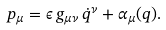Convert formula to latex. <formula><loc_0><loc_0><loc_500><loc_500>p _ { \mu } = \epsilon \, g _ { \mu \nu } \, \dot { q } ^ { \nu } + \alpha _ { \mu } ( q ) .</formula> 